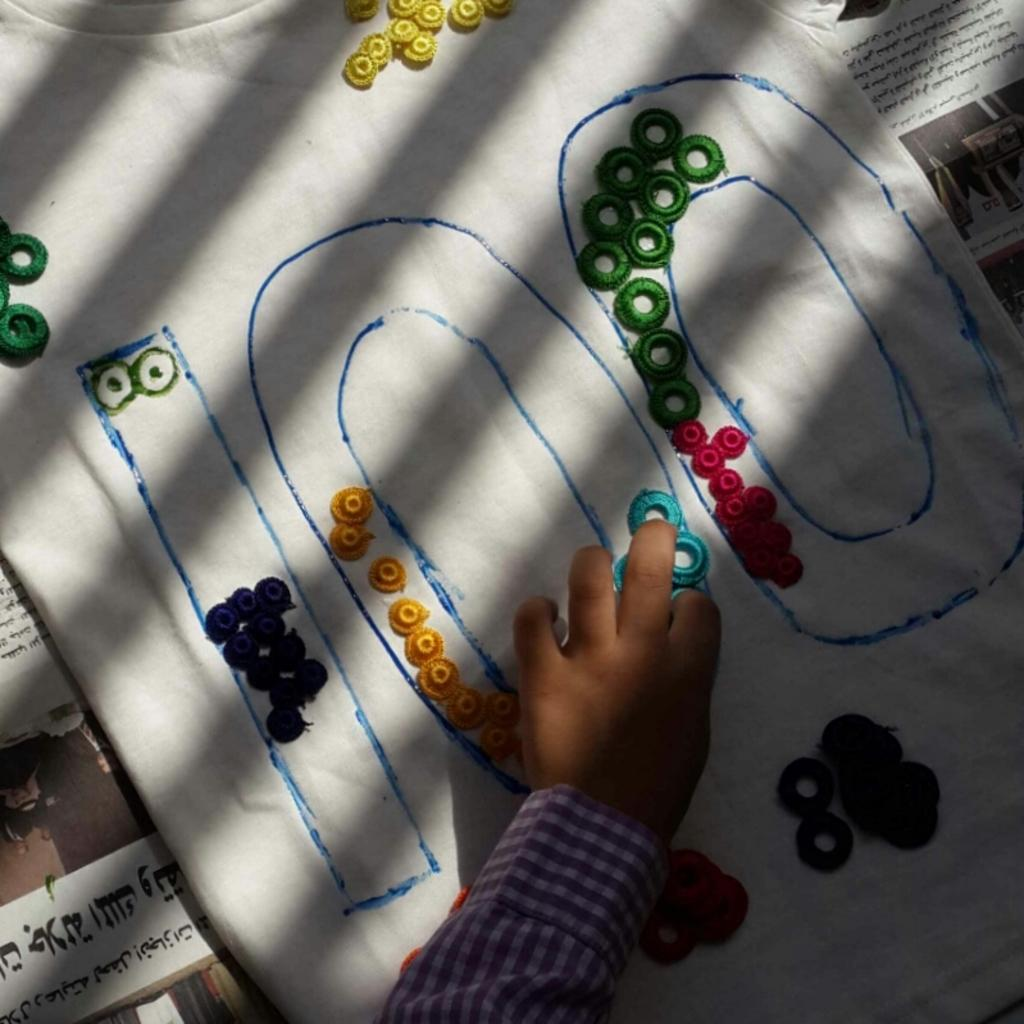What can be seen in the image? There are objects in the image. Can you describe a specific part of the image? There is a hand on a cloth in the image. What type of reading material is present in the image? There are newspapers in the image. How many trucks are visible in the image? There are no trucks visible in the image. What type of motion is occurring in the image? The image does not depict any motion; it is a still image. 